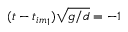Convert formula to latex. <formula><loc_0><loc_0><loc_500><loc_500>( t - { t _ { i m } } _ { 1 } ) \sqrt { g / d } = - 1</formula> 